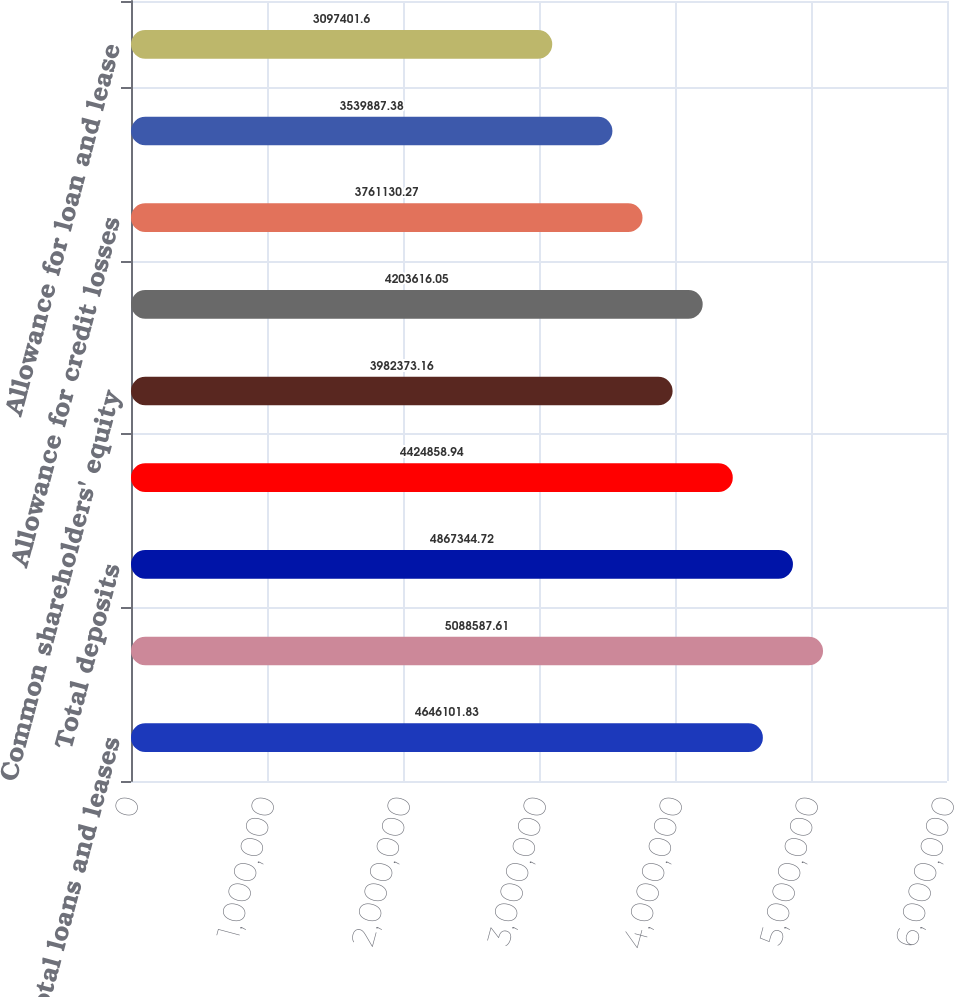Convert chart to OTSL. <chart><loc_0><loc_0><loc_500><loc_500><bar_chart><fcel>Total loans and leases<fcel>Total assets<fcel>Total deposits<fcel>Long-term debt<fcel>Common shareholders' equity<fcel>Total shareholders' equity<fcel>Allowance for credit losses<fcel>Nonperforming loans leases and<fcel>Allowance for loan and lease<nl><fcel>4.6461e+06<fcel>5.08859e+06<fcel>4.86734e+06<fcel>4.42486e+06<fcel>3.98237e+06<fcel>4.20362e+06<fcel>3.76113e+06<fcel>3.53989e+06<fcel>3.0974e+06<nl></chart> 